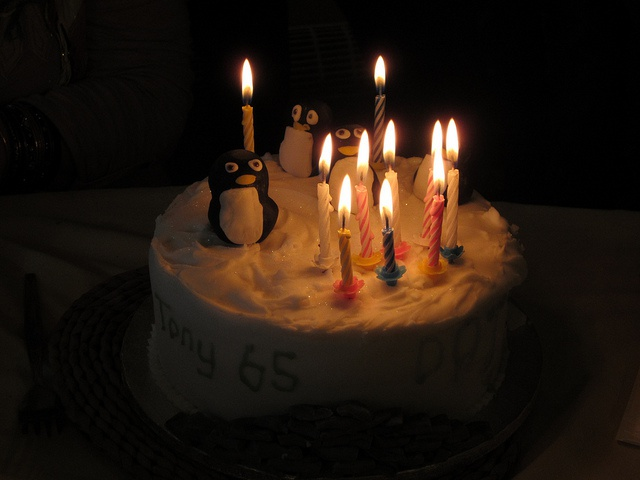Describe the objects in this image and their specific colors. I can see a cake in black, brown, and maroon tones in this image. 